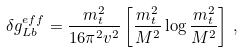Convert formula to latex. <formula><loc_0><loc_0><loc_500><loc_500>\delta g ^ { e f f } _ { L b } = \frac { m _ { t } ^ { 2 } } { 1 6 \pi ^ { 2 } v ^ { 2 } } \left [ \frac { m _ { t } ^ { 2 } } { M ^ { 2 } } \log \frac { m _ { t } ^ { 2 } } { M ^ { 2 } } \right ] \, ,</formula> 